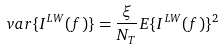<formula> <loc_0><loc_0><loc_500><loc_500>v a r \{ I ^ { L W } ( f ) \} = \frac { \xi } { N _ { T } } E \{ I ^ { L W } ( f ) \} ^ { 2 }</formula> 